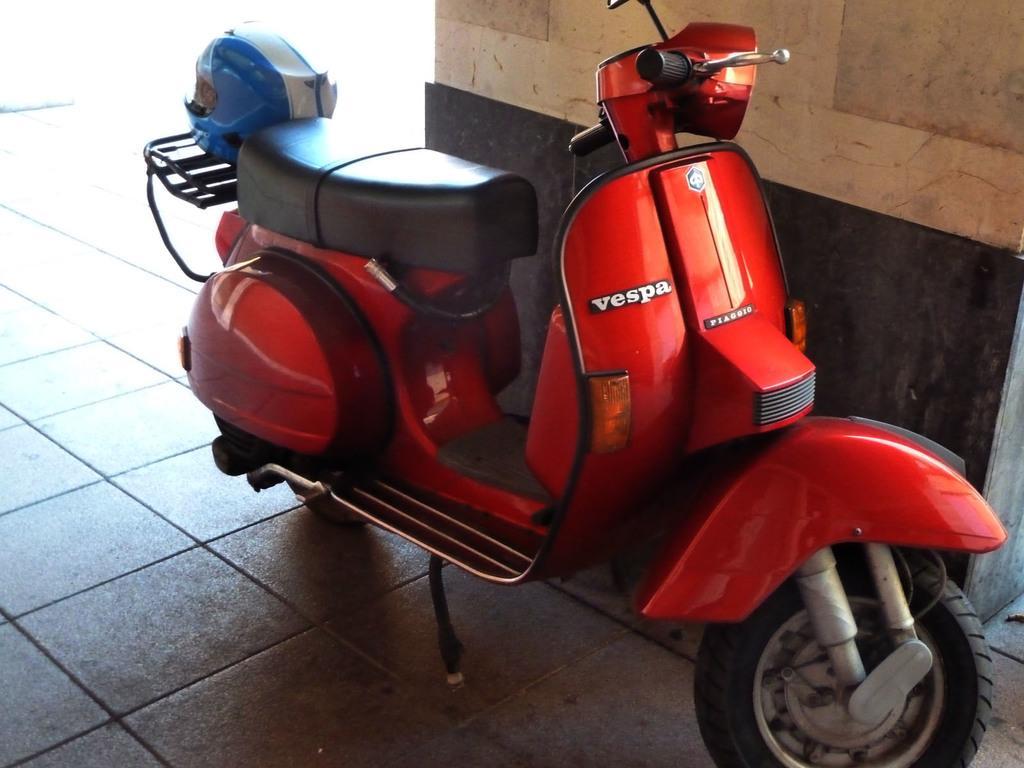Could you give a brief overview of what you see in this image? In this picture there is a red color vehicle in the foreground and there is text and there is a helmet on the vehicle. Behind the vehicle there is a pillar. At the bottom there is a floor. 